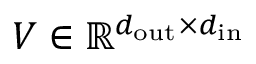Convert formula to latex. <formula><loc_0><loc_0><loc_500><loc_500>V \in \mathbb { R } ^ { d _ { o u t } \times d _ { i n } }</formula> 